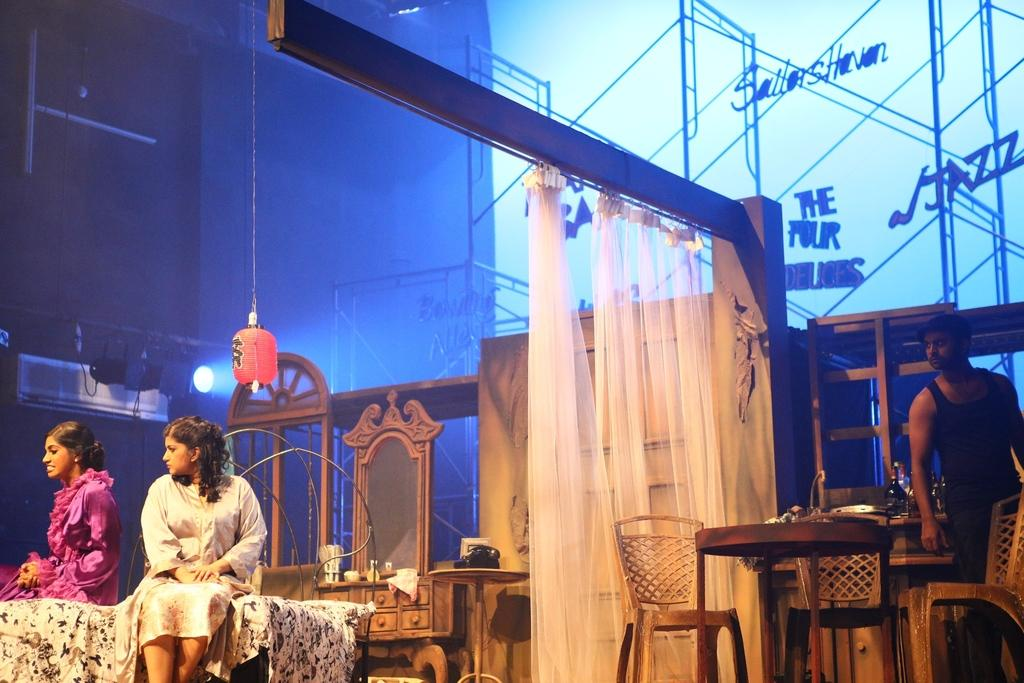How many people are present in the image? There are 2 women sitting and 1 man standing, making a total of 3 people in the image. What are the women doing in the image? The women are sitting in the image. What is the man doing in the image? The man is standing in the image. What furniture is present in the image? There is a table and 3 chairs around the table in the image. What can be seen in the background of the image? In the background, there are curtains and a dressing table. What type of apparel is being used to promote peace in the image? There is no apparel or promotion of peace present in the image. Is there any milk visible in the image? There is no milk visible in the image. 